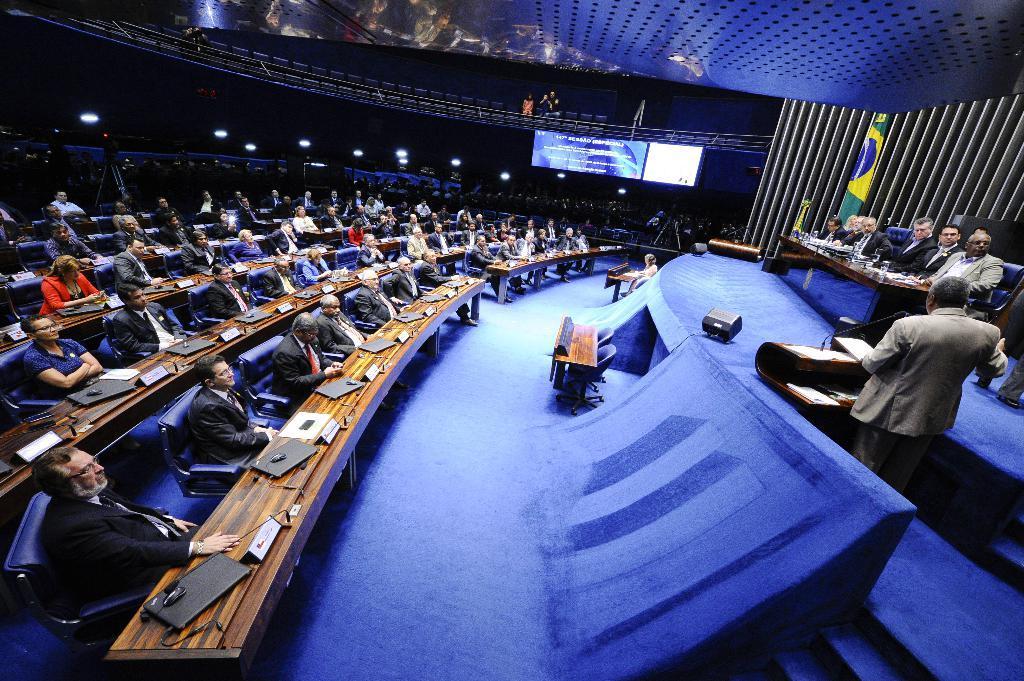Please provide a concise description of this image. In this image I can see number of persons are sitting in chairs in front of a desk. On the desk I can see laptops, mouses and few boards. To the right side of the image I can see a person standing, a microphone, few persons sitting on chairs in front of a desk. In the background I can see a huge screen, the ceiling, a flag, few persons and few lights. 